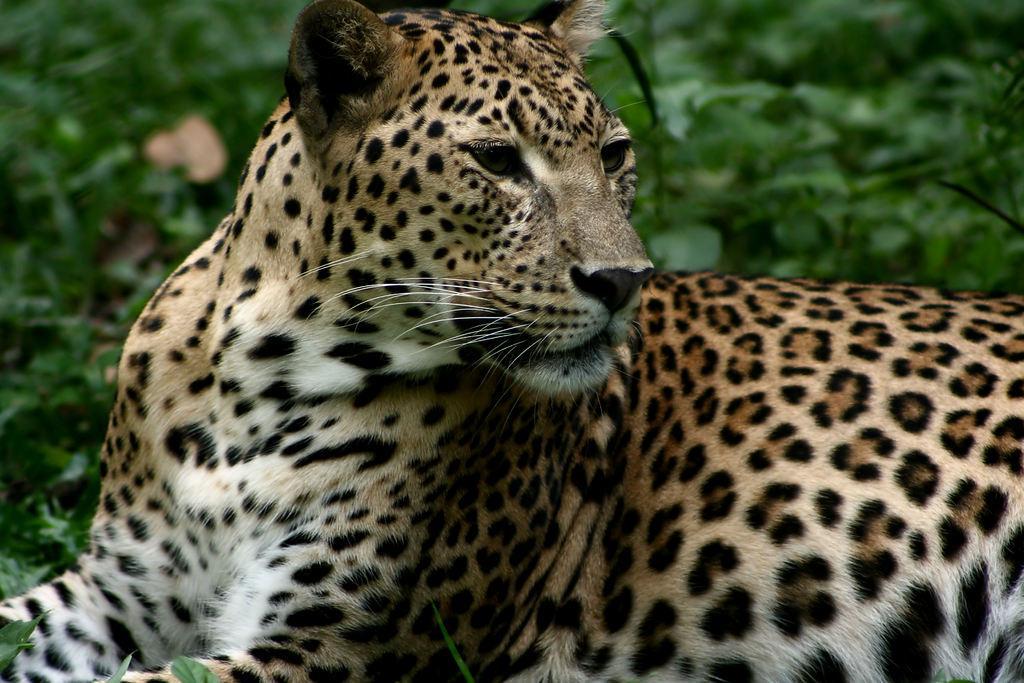Could you give a brief overview of what you see in this image? In this image we can see a leopard is sitting and in the background there are plants. 